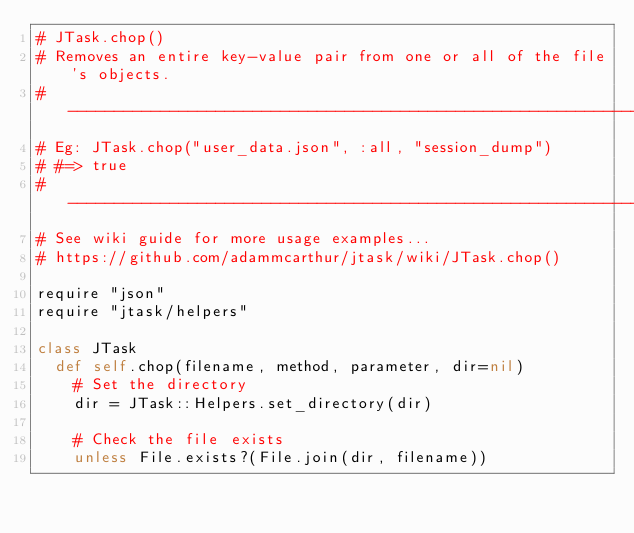<code> <loc_0><loc_0><loc_500><loc_500><_Ruby_># JTask.chop()
# Removes an entire key-value pair from one or all of the file's objects.
# ------------------------------------------------------------------------------
# Eg: JTask.chop("user_data.json", :all, "session_dump")
# #=> true
# ------------------------------------------------------------------------------
# See wiki guide for more usage examples...
# https://github.com/adammcarthur/jtask/wiki/JTask.chop()

require "json"
require "jtask/helpers"

class JTask
  def self.chop(filename, method, parameter, dir=nil)
    # Set the directory
    dir = JTask::Helpers.set_directory(dir)

    # Check the file exists
    unless File.exists?(File.join(dir, filename))</code> 